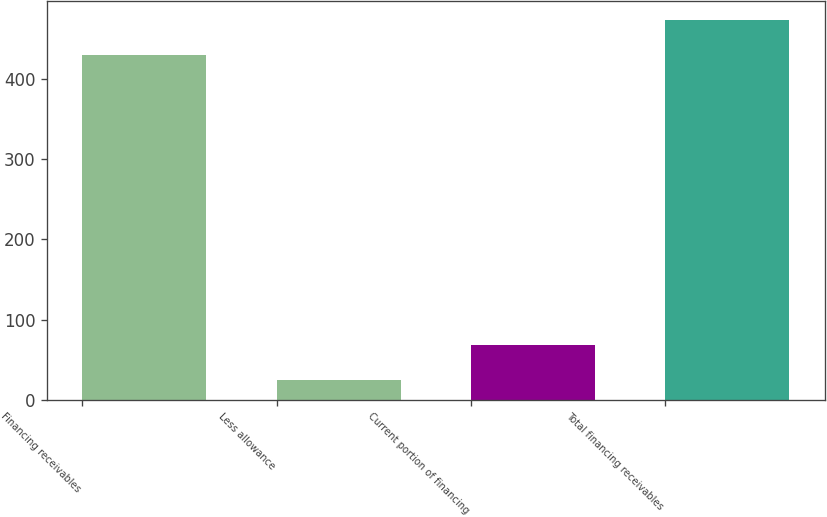Convert chart. <chart><loc_0><loc_0><loc_500><loc_500><bar_chart><fcel>Financing receivables<fcel>Less allowance<fcel>Current portion of financing<fcel>Total financing receivables<nl><fcel>430<fcel>24<fcel>68.4<fcel>474.4<nl></chart> 